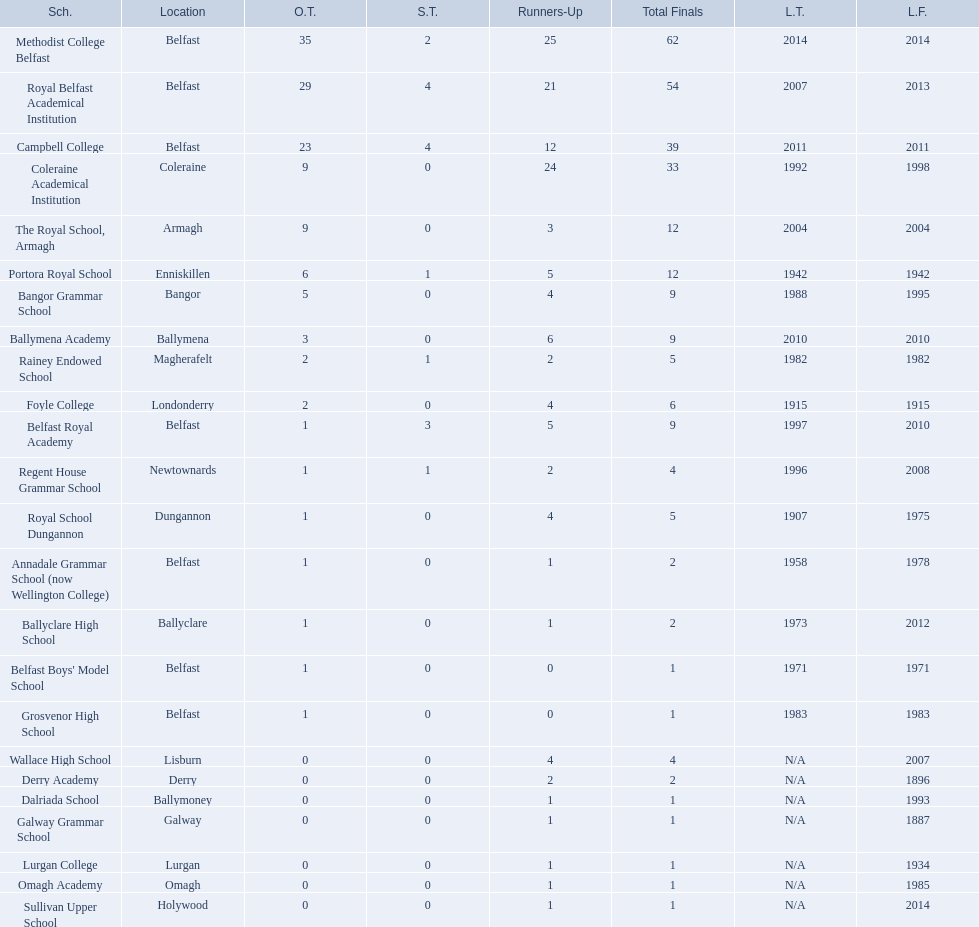What is the most recent win of campbell college? 2011. What is the most recent win of regent house grammar school? 1996. Which date is more recent? 2011. What is the name of the school with this date? Campbell College. 